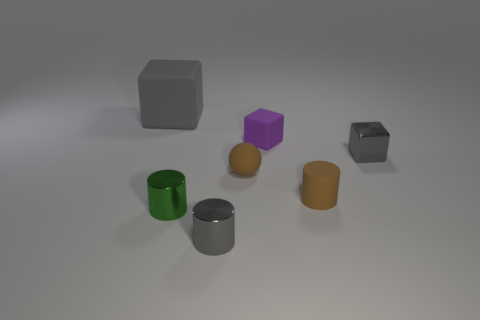Is there anything else that has the same size as the gray rubber cube?
Ensure brevity in your answer.  No. There is a matte cube that is the same size as the brown cylinder; what color is it?
Ensure brevity in your answer.  Purple. How many other objects are the same shape as the large gray matte object?
Your response must be concise. 2. Are there any brown cylinders made of the same material as the small sphere?
Your answer should be compact. Yes. Do the gray cube that is behind the purple rubber block and the small brown thing behind the small brown rubber cylinder have the same material?
Offer a terse response. Yes. What number of brown matte balls are there?
Offer a terse response. 1. What shape is the gray metal object to the right of the small purple cube?
Your answer should be compact. Cube. What number of other objects are there of the same size as the ball?
Your response must be concise. 5. There is a brown object that is on the right side of the small brown matte ball; is its shape the same as the gray object in front of the brown cylinder?
Provide a succinct answer. Yes. There is a tiny gray cylinder; what number of gray cylinders are left of it?
Your response must be concise. 0. 